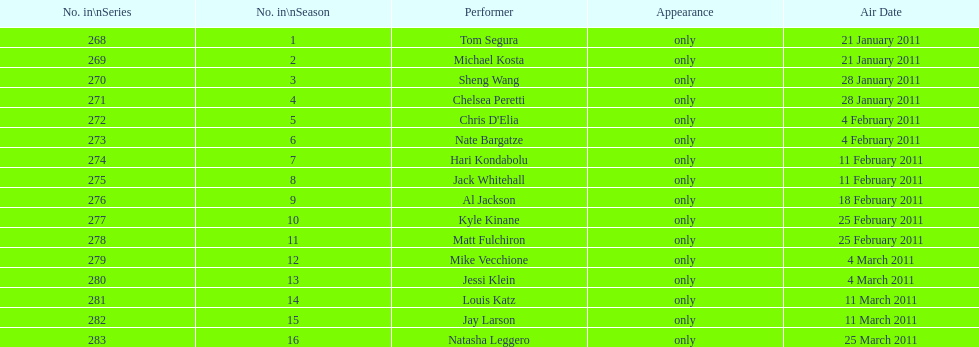Who debuted first, tom segura or jay larson? Tom Segura. 